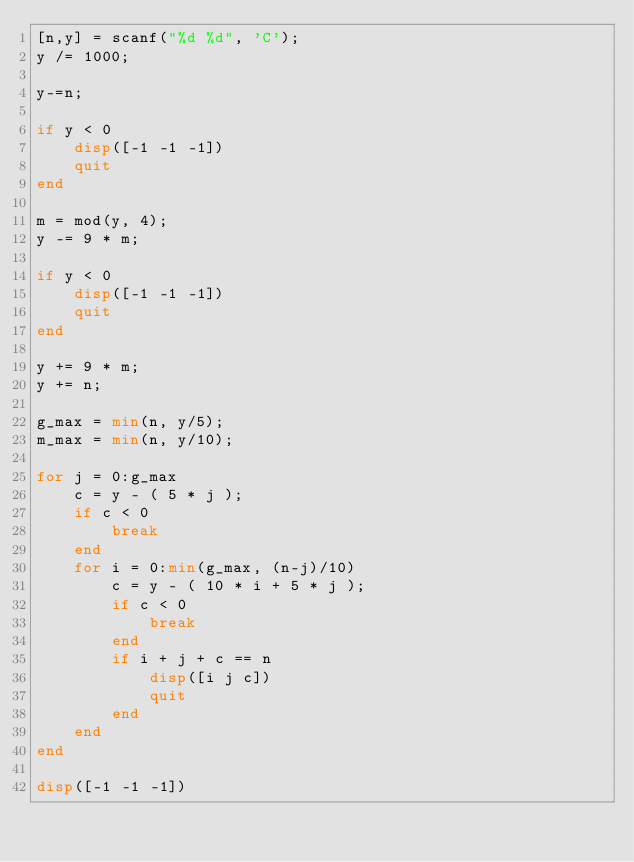<code> <loc_0><loc_0><loc_500><loc_500><_Octave_>[n,y] = scanf("%d %d", 'C');
y /= 1000;

y-=n;

if y < 0
    disp([-1 -1 -1])
    quit
end

m = mod(y, 4);
y -= 9 * m;

if y < 0
    disp([-1 -1 -1])
    quit
end

y += 9 * m;
y += n;

g_max = min(n, y/5);
m_max = min(n, y/10);

for j = 0:g_max
    c = y - ( 5 * j );
    if c < 0
        break
    end
    for i = 0:min(g_max, (n-j)/10)
        c = y - ( 10 * i + 5 * j );
        if c < 0
            break
        end
        if i + j + c == n
            disp([i j c])
            quit
        end
    end
end

disp([-1 -1 -1])
</code> 